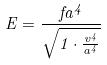Convert formula to latex. <formula><loc_0><loc_0><loc_500><loc_500>E = \frac { f a ^ { 4 } } { \sqrt { 1 \cdot \frac { v ^ { 4 } } { a ^ { 4 } } } }</formula> 